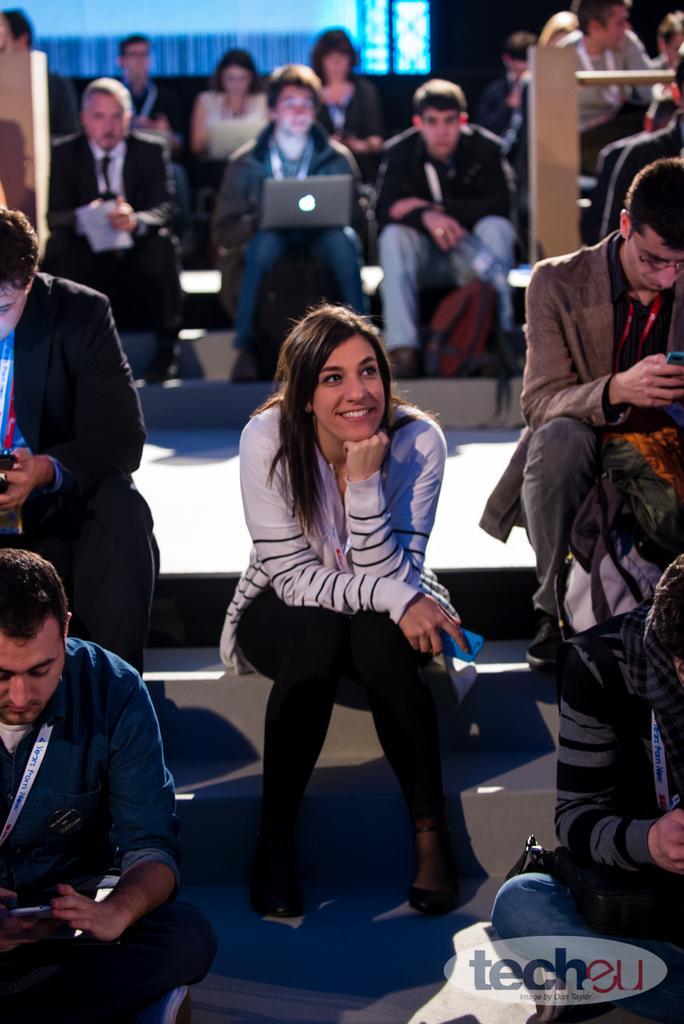Please provide a concise description of this image. In the center of the image some persons are sitting and holding a mobile in there hands. In the background of the image some persons are sitting. In the middle of the image a man is sitting and holding a laptop. At the bottom of the image floor is there. At the top of the image wall is present. 